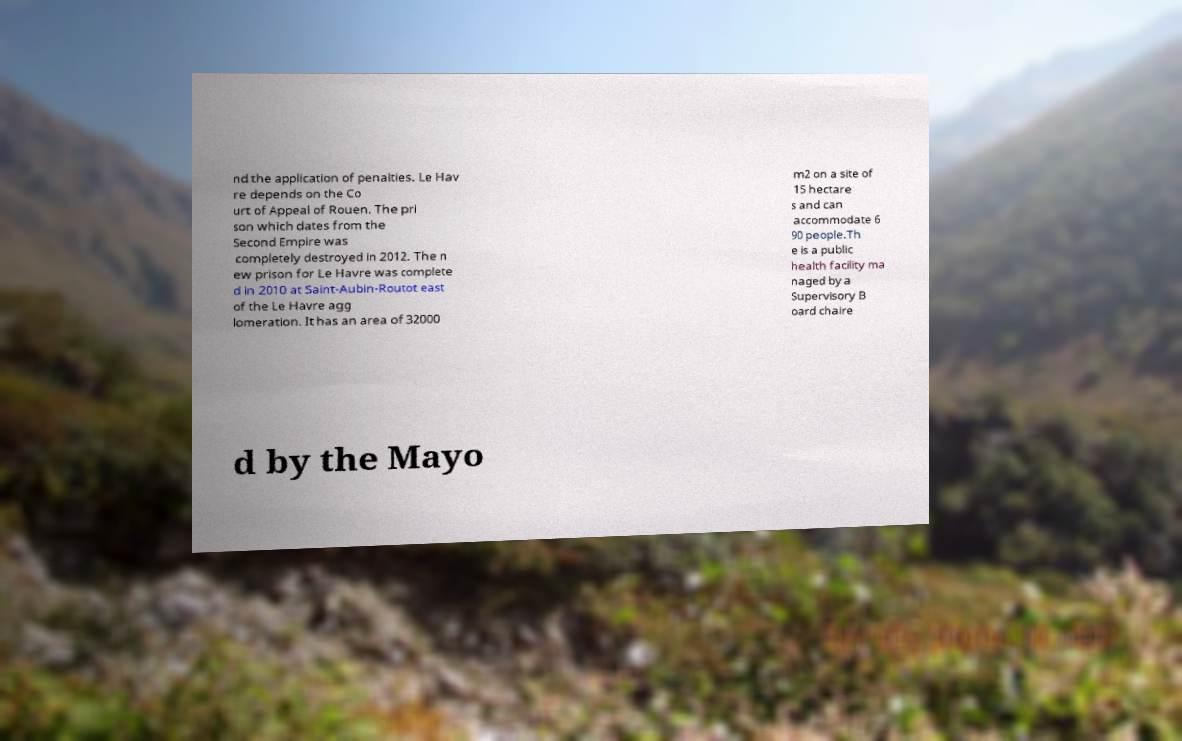Can you read and provide the text displayed in the image?This photo seems to have some interesting text. Can you extract and type it out for me? nd the application of penalties. Le Hav re depends on the Co urt of Appeal of Rouen. The pri son which dates from the Second Empire was completely destroyed in 2012. The n ew prison for Le Havre was complete d in 2010 at Saint-Aubin-Routot east of the Le Havre agg lomeration. It has an area of 32000 m2 on a site of 15 hectare s and can accommodate 6 90 people.Th e is a public health facility ma naged by a Supervisory B oard chaire d by the Mayo 